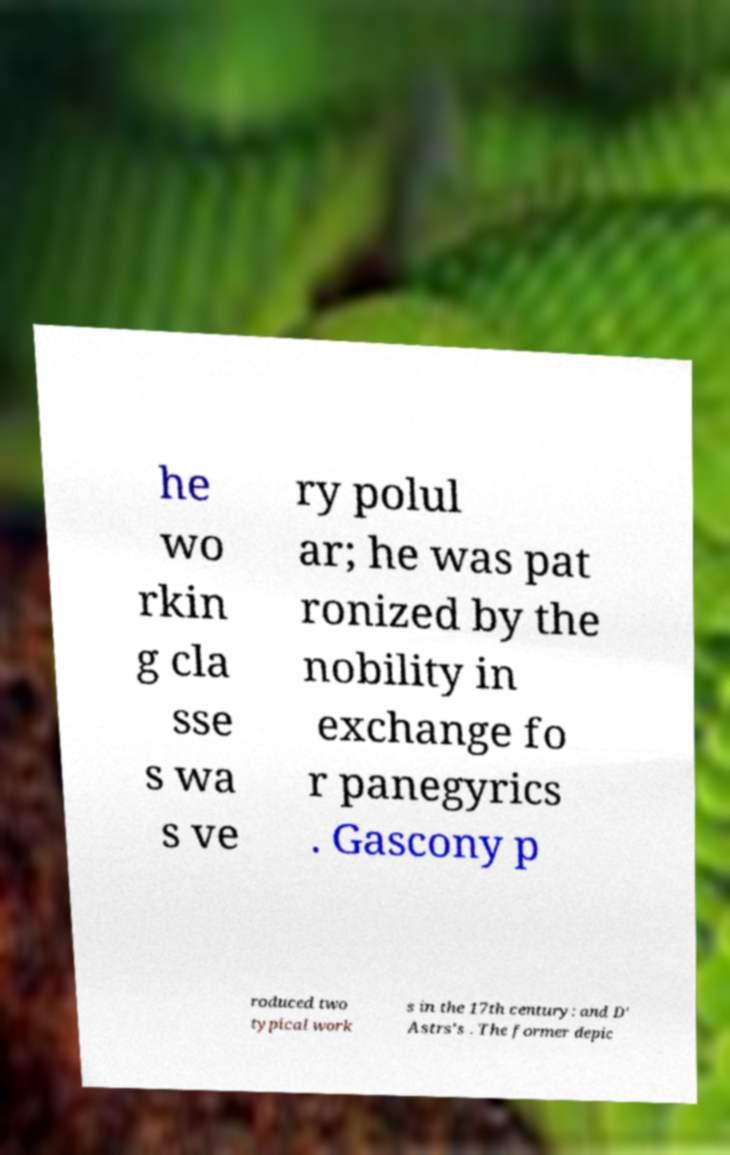Could you extract and type out the text from this image? he wo rkin g cla sse s wa s ve ry polul ar; he was pat ronized by the nobility in exchange fo r panegyrics . Gascony p roduced two typical work s in the 17th century: and D' Astrs's . The former depic 